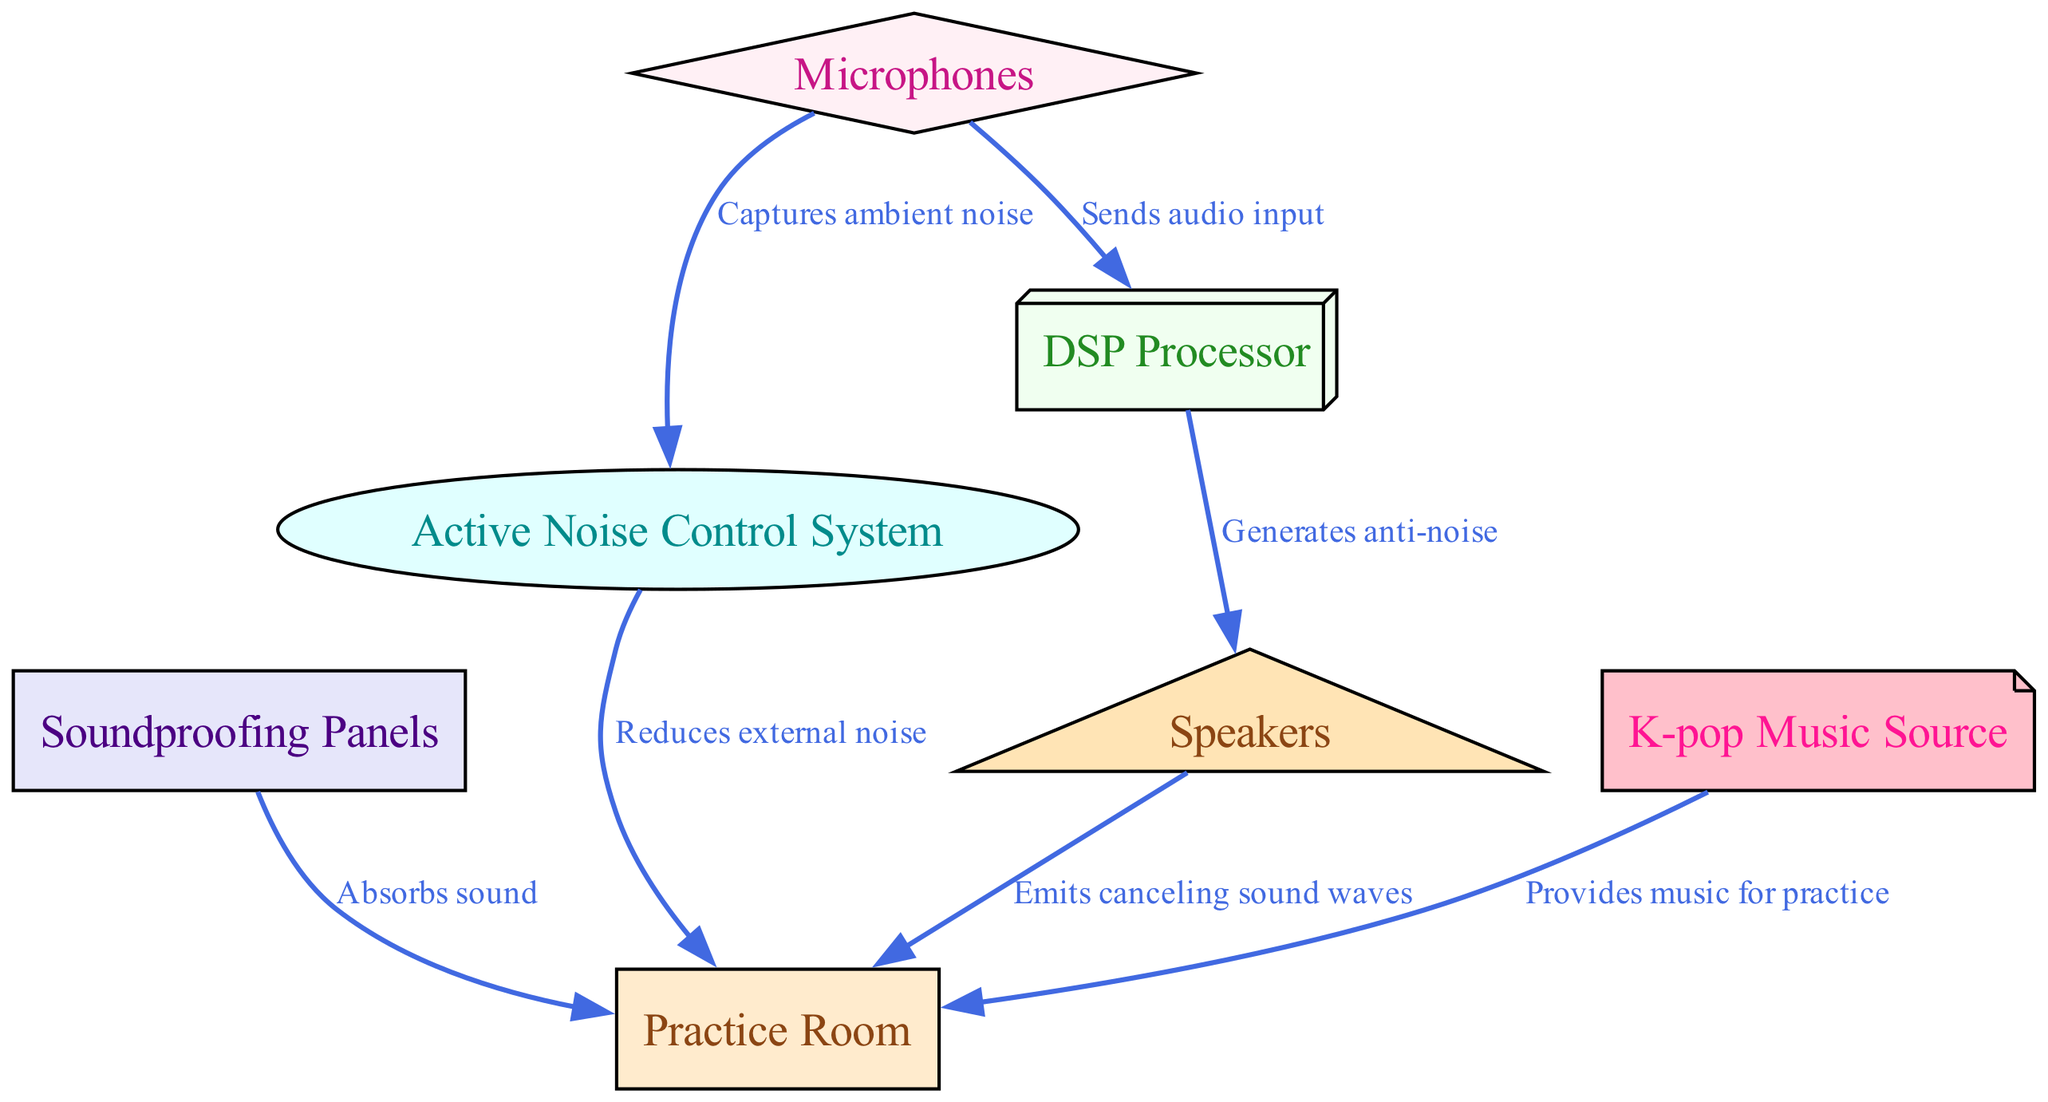What is the main purpose of the Soundproofing Panels? The Soundproofing Panels are labeled as "Absorbs sound," indicating their primary function of reducing sound levels within the Practice Room.
Answer: Absorbs sound How many nodes are present in the diagram? By counting the individual nodes listed, we can see there are 7 distinct entities shown in the diagram: Practice Room, Soundproofing Panels, Active Noise Control System, Microphones, DSP Processor, Speakers, and K-pop Music Source.
Answer: 7 Which component captures ambient noise? The arrow from the Microphones points to the Active Noise Control System, and its label states "Captures ambient noise," clearly indicating that this function is performed by the Microphones.
Answer: Microphones What does the DSP Processor generate? According to the edge leading from the DSP Processor to Speakers, it states "Generates anti-noise," which provides direct information about the function of the DSP Processor in the system.
Answer: Generates anti-noise How many edges are connecting the nodes? Upon counting the connections between different components of the diagram, we note there are 6 edges that connect the nodes, illustrating the relationships and processes involved in the noise cancellation system.
Answer: 6 What is the relationship between K-pop Music Source and Practice Room? The K-pop Music Source has a direct connection to the Practice Room and is labeled "Provides music for practice," indicating that this source plays an essential role in the Functionality of the practice space.
Answer: Provides music for practice Which component emits canceling sound waves? The edge from Speakers to Practice Room states "Emits canceling sound waves," directly indicating that the Speakers are responsible for this action in the noise cancellation system.
Answer: Speakers What is the function of the Active Noise Control System? The Active Noise Control System is connected to the Practice Room with the label "Reduces external noise," describing its primary function in the context of the diagram.
Answer: Reduces external noise 